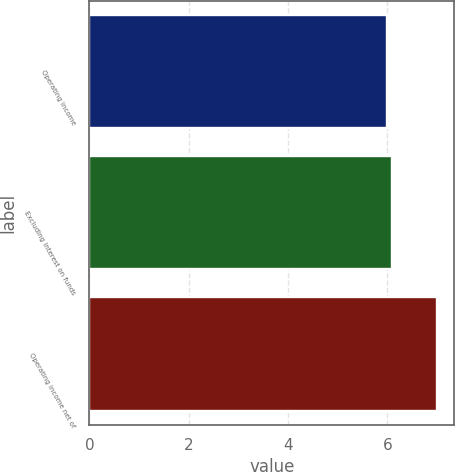Convert chart. <chart><loc_0><loc_0><loc_500><loc_500><bar_chart><fcel>Operating income<fcel>Excluding Interest on funds<fcel>Operating income net of<nl><fcel>6<fcel>6.1<fcel>7<nl></chart> 